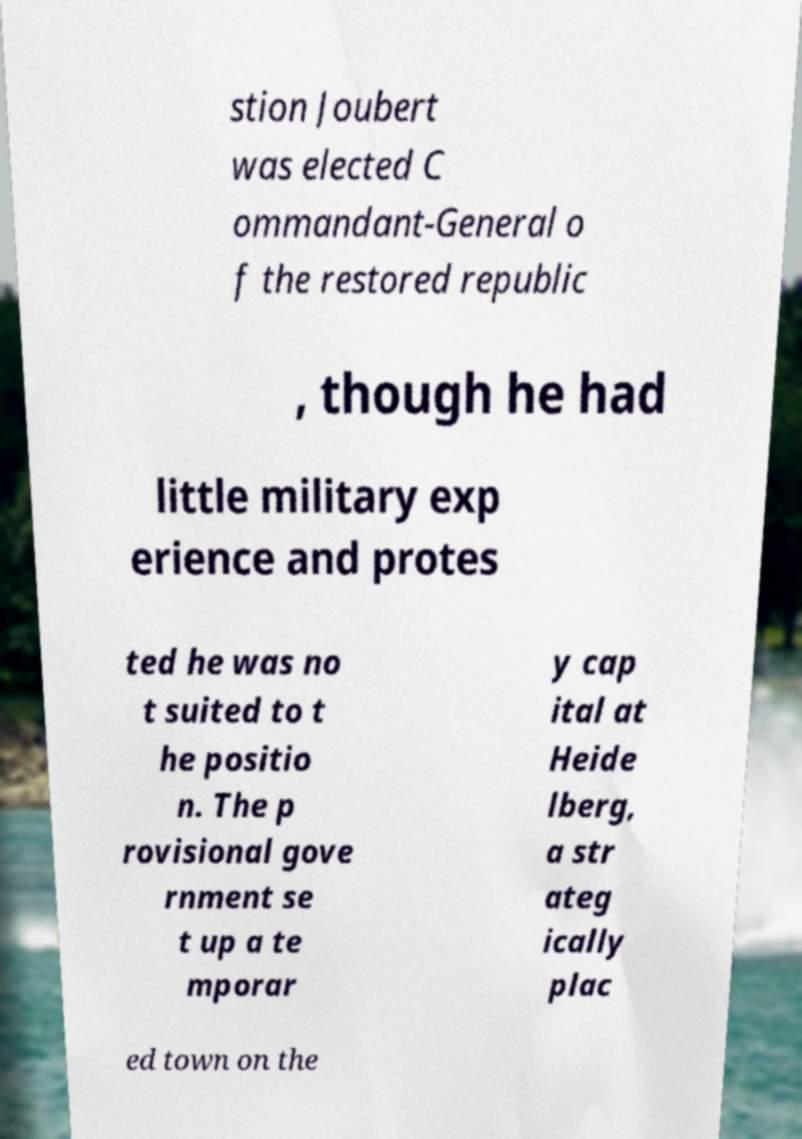Could you assist in decoding the text presented in this image and type it out clearly? stion Joubert was elected C ommandant-General o f the restored republic , though he had little military exp erience and protes ted he was no t suited to t he positio n. The p rovisional gove rnment se t up a te mporar y cap ital at Heide lberg, a str ateg ically plac ed town on the 